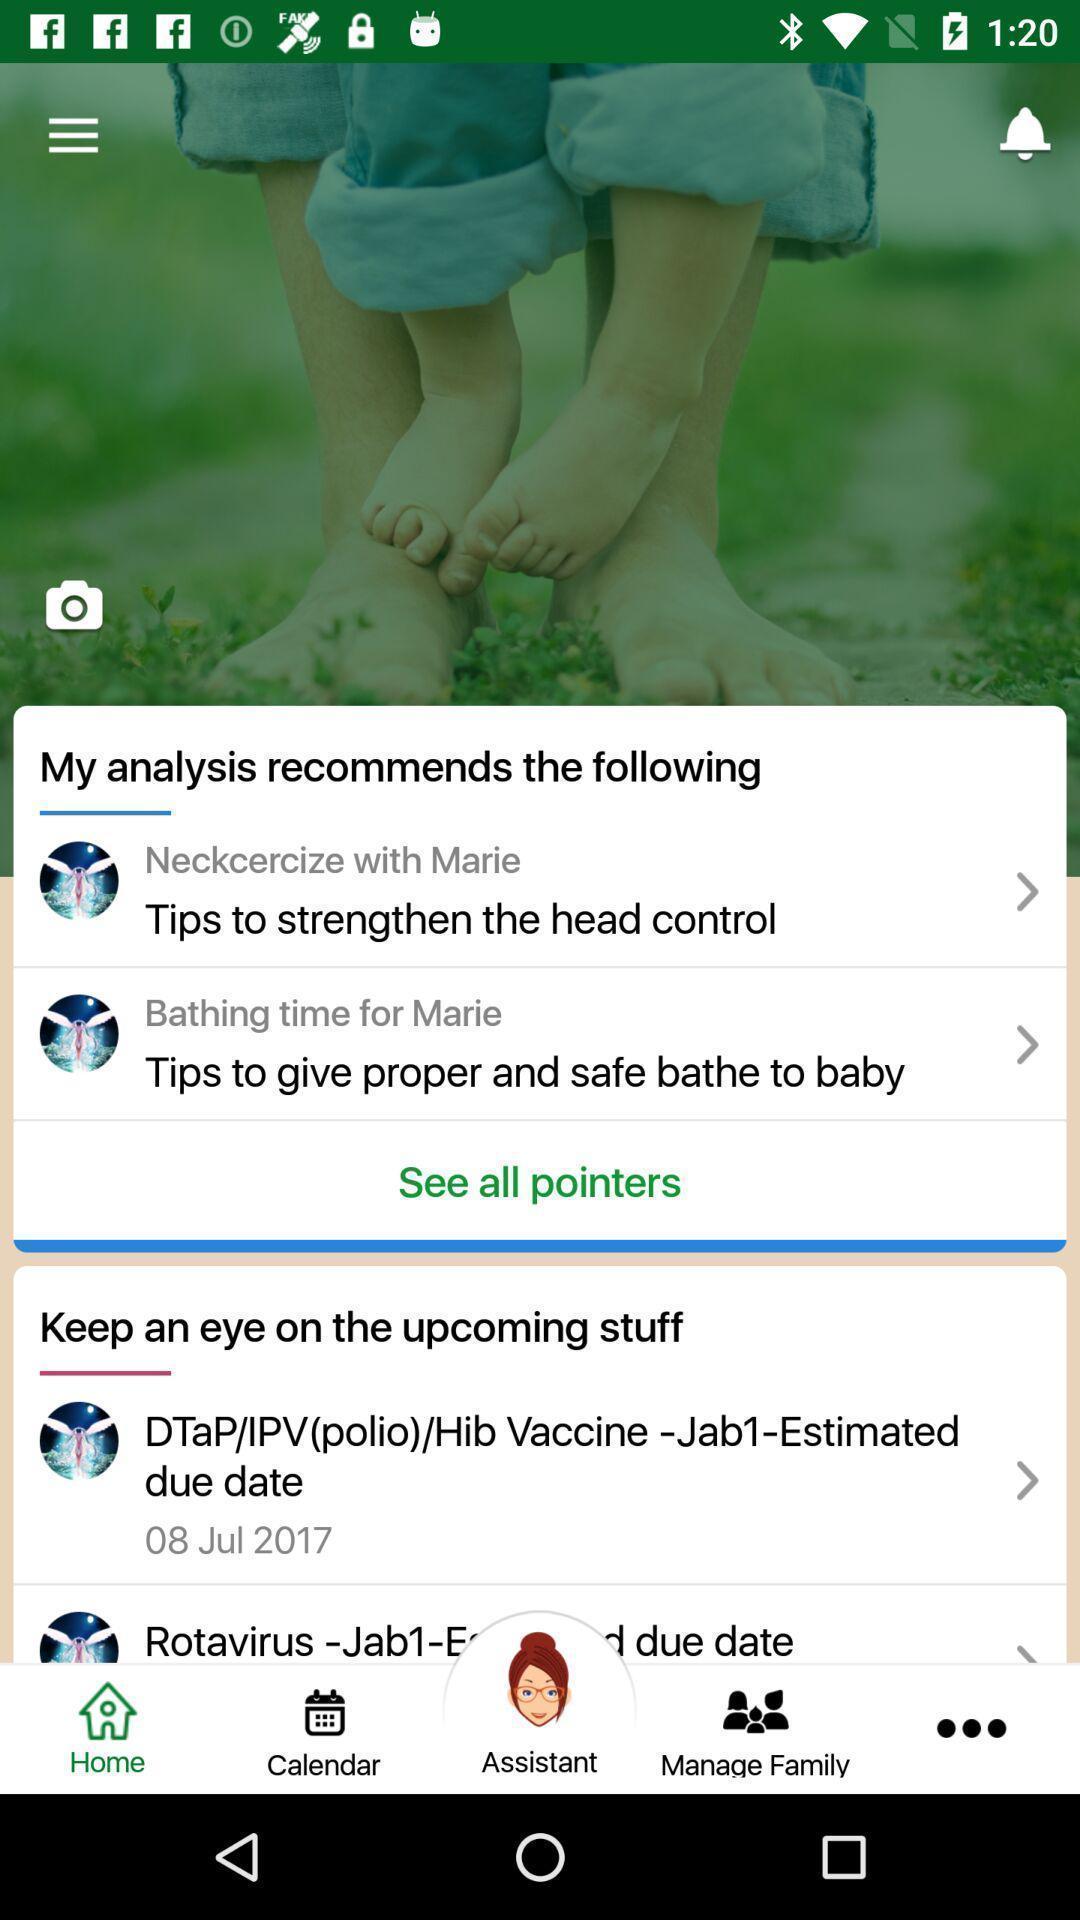What details can you identify in this image? Screen showing page. 